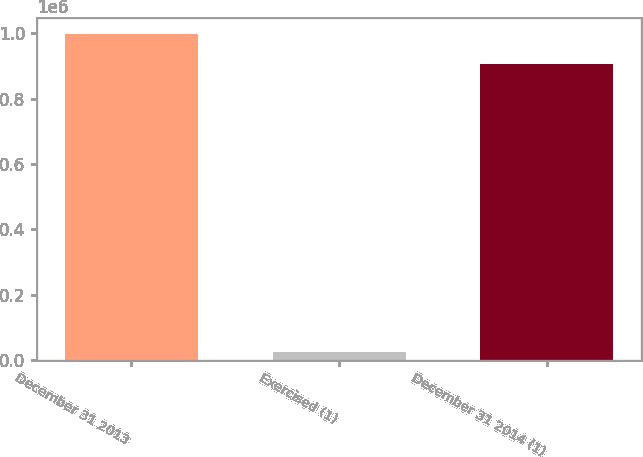Convert chart. <chart><loc_0><loc_0><loc_500><loc_500><bar_chart><fcel>December 31 2013<fcel>Exercised (1)<fcel>December 31 2014 (1)<nl><fcel>997391<fcel>25039<fcel>906719<nl></chart> 